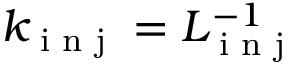Convert formula to latex. <formula><loc_0><loc_0><loc_500><loc_500>k _ { i n j } = L _ { i n j } ^ { - 1 }</formula> 